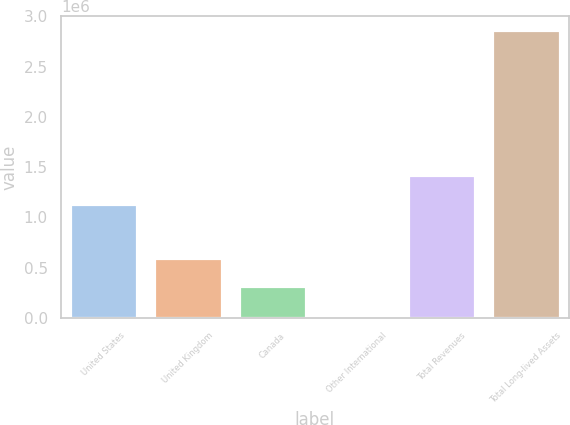Convert chart. <chart><loc_0><loc_0><loc_500><loc_500><bar_chart><fcel>United States<fcel>United Kingdom<fcel>Canada<fcel>Other International<fcel>Total Revenues<fcel>Total Long-lived Assets<nl><fcel>1.134e+06<fcel>596845<fcel>313499<fcel>30153<fcel>1.41735e+06<fcel>2.86362e+06<nl></chart> 